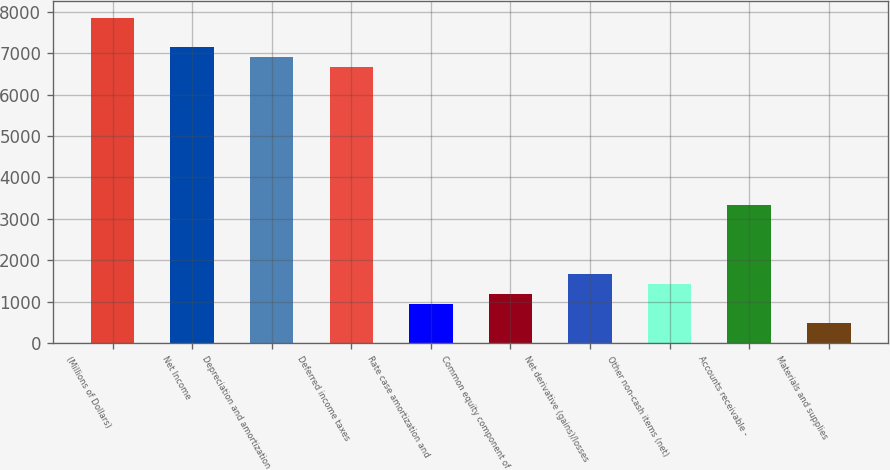<chart> <loc_0><loc_0><loc_500><loc_500><bar_chart><fcel>(Millions of Dollars)<fcel>Net Income<fcel>Depreciation and amortization<fcel>Deferred income taxes<fcel>Rate case amortization and<fcel>Common equity component of<fcel>Net derivative (gains)/losses<fcel>Other non-cash items (net)<fcel>Accounts receivable -<fcel>Materials and supplies<nl><fcel>7855<fcel>7141<fcel>6903<fcel>6665<fcel>953<fcel>1191<fcel>1667<fcel>1429<fcel>3333<fcel>477<nl></chart> 